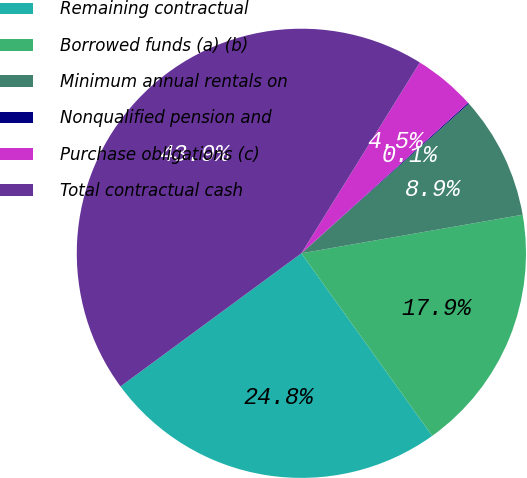Convert chart to OTSL. <chart><loc_0><loc_0><loc_500><loc_500><pie_chart><fcel>Remaining contractual<fcel>Borrowed funds (a) (b)<fcel>Minimum annual rentals on<fcel>Nonqualified pension and<fcel>Purchase obligations (c)<fcel>Total contractual cash<nl><fcel>24.8%<fcel>17.85%<fcel>8.86%<fcel>0.08%<fcel>4.47%<fcel>43.94%<nl></chart> 